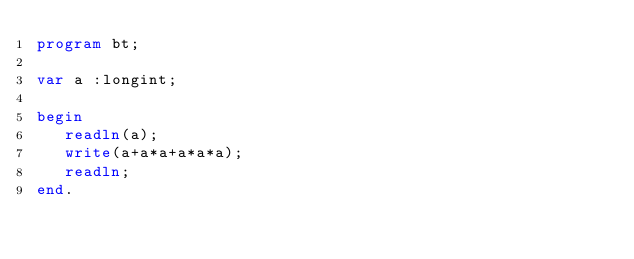Convert code to text. <code><loc_0><loc_0><loc_500><loc_500><_Pascal_>program bt;

var a :longint;

begin
   readln(a);
   write(a+a*a+a*a*a);
   readln;
end.</code> 